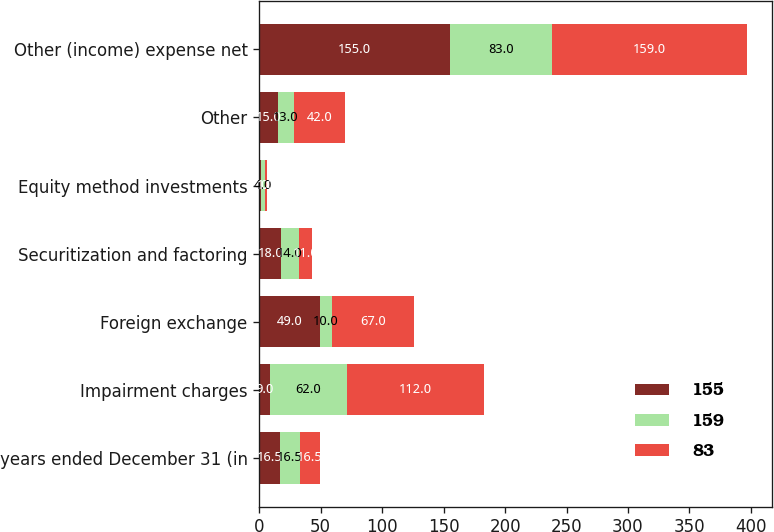<chart> <loc_0><loc_0><loc_500><loc_500><stacked_bar_chart><ecel><fcel>years ended December 31 (in<fcel>Impairment charges<fcel>Foreign exchange<fcel>Securitization and factoring<fcel>Equity method investments<fcel>Other<fcel>Other (income) expense net<nl><fcel>155<fcel>16.5<fcel>9<fcel>49<fcel>18<fcel>1<fcel>15<fcel>155<nl><fcel>159<fcel>16.5<fcel>62<fcel>10<fcel>14<fcel>4<fcel>13<fcel>83<nl><fcel>83<fcel>16.5<fcel>112<fcel>67<fcel>11<fcel>1<fcel>42<fcel>159<nl></chart> 